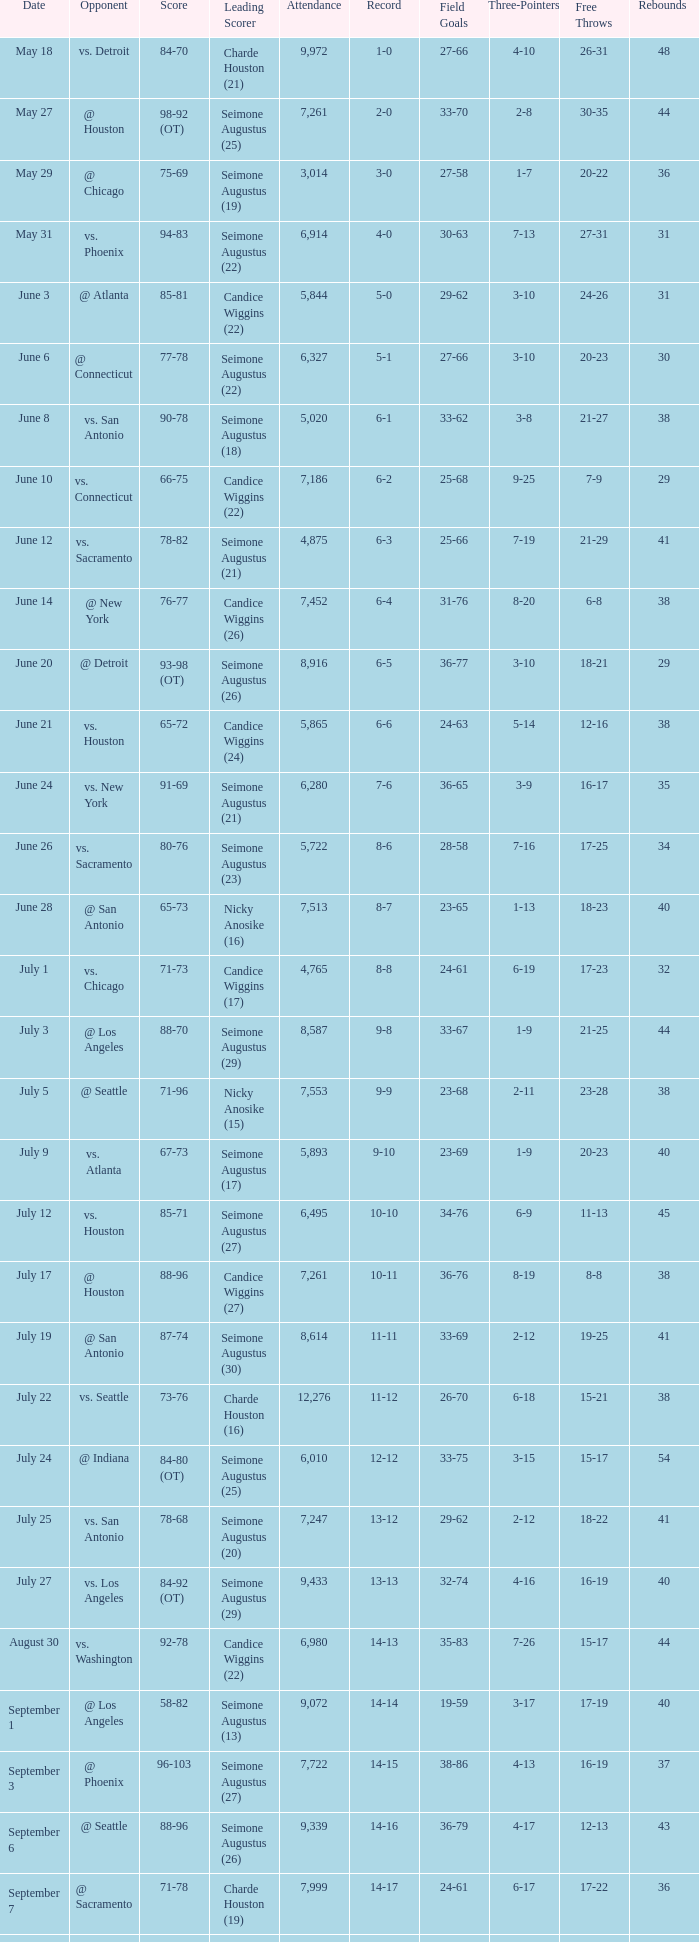Could you parse the entire table? {'header': ['Date', 'Opponent', 'Score', 'Leading Scorer', 'Attendance', 'Record', 'Field Goals', 'Three-Pointers', 'Free Throws', 'Rebounds '], 'rows': [['May 18', 'vs. Detroit', '84-70', 'Charde Houston (21)', '9,972', '1-0', '27-66', '4-10', '26-31', '48'], ['May 27', '@ Houston', '98-92 (OT)', 'Seimone Augustus (25)', '7,261', '2-0', '33-70', '2-8', '30-35', '44'], ['May 29', '@ Chicago', '75-69', 'Seimone Augustus (19)', '3,014', '3-0', '27-58', '1-7', '20-22', '36'], ['May 31', 'vs. Phoenix', '94-83', 'Seimone Augustus (22)', '6,914', '4-0', '30-63', '7-13', '27-31', '31'], ['June 3', '@ Atlanta', '85-81', 'Candice Wiggins (22)', '5,844', '5-0', '29-62', '3-10', '24-26', '31'], ['June 6', '@ Connecticut', '77-78', 'Seimone Augustus (22)', '6,327', '5-1', '27-66', '3-10', '20-23', '30'], ['June 8', 'vs. San Antonio', '90-78', 'Seimone Augustus (18)', '5,020', '6-1', '33-62', '3-8', '21-27', '38'], ['June 10', 'vs. Connecticut', '66-75', 'Candice Wiggins (22)', '7,186', '6-2', '25-68', '9-25', '7-9', '29'], ['June 12', 'vs. Sacramento', '78-82', 'Seimone Augustus (21)', '4,875', '6-3', '25-66', '7-19', '21-29', '41'], ['June 14', '@ New York', '76-77', 'Candice Wiggins (26)', '7,452', '6-4', '31-76', '8-20', '6-8', '38'], ['June 20', '@ Detroit', '93-98 (OT)', 'Seimone Augustus (26)', '8,916', '6-5', '36-77', '3-10', '18-21', '29'], ['June 21', 'vs. Houston', '65-72', 'Candice Wiggins (24)', '5,865', '6-6', '24-63', '5-14', '12-16', '38'], ['June 24', 'vs. New York', '91-69', 'Seimone Augustus (21)', '6,280', '7-6', '36-65', '3-9', '16-17', '35'], ['June 26', 'vs. Sacramento', '80-76', 'Seimone Augustus (23)', '5,722', '8-6', '28-58', '7-16', '17-25', '34'], ['June 28', '@ San Antonio', '65-73', 'Nicky Anosike (16)', '7,513', '8-7', '23-65', '1-13', '18-23', '40'], ['July 1', 'vs. Chicago', '71-73', 'Candice Wiggins (17)', '4,765', '8-8', '24-61', '6-19', '17-23', '32'], ['July 3', '@ Los Angeles', '88-70', 'Seimone Augustus (29)', '8,587', '9-8', '33-67', '1-9', '21-25', '44'], ['July 5', '@ Seattle', '71-96', 'Nicky Anosike (15)', '7,553', '9-9', '23-68', '2-11', '23-28', '38'], ['July 9', 'vs. Atlanta', '67-73', 'Seimone Augustus (17)', '5,893', '9-10', '23-69', '1-9', '20-23', '40'], ['July 12', 'vs. Houston', '85-71', 'Seimone Augustus (27)', '6,495', '10-10', '34-76', '6-9', '11-13', '45'], ['July 17', '@ Houston', '88-96', 'Candice Wiggins (27)', '7,261', '10-11', '36-76', '8-19', '8-8', '38'], ['July 19', '@ San Antonio', '87-74', 'Seimone Augustus (30)', '8,614', '11-11', '33-69', '2-12', '19-25', '41'], ['July 22', 'vs. Seattle', '73-76', 'Charde Houston (16)', '12,276', '11-12', '26-70', '6-18', '15-21', '38'], ['July 24', '@ Indiana', '84-80 (OT)', 'Seimone Augustus (25)', '6,010', '12-12', '33-75', '3-15', '15-17', '54'], ['July 25', 'vs. San Antonio', '78-68', 'Seimone Augustus (20)', '7,247', '13-12', '29-62', '2-12', '18-22', '41'], ['July 27', 'vs. Los Angeles', '84-92 (OT)', 'Seimone Augustus (29)', '9,433', '13-13', '32-74', '4-16', '16-19', '40'], ['August 30', 'vs. Washington', '92-78', 'Candice Wiggins (22)', '6,980', '14-13', '35-83', '7-26', '15-17', '44'], ['September 1', '@ Los Angeles', '58-82', 'Seimone Augustus (13)', '9,072', '14-14', '19-59', '3-17', '17-19', '40'], ['September 3', '@ Phoenix', '96-103', 'Seimone Augustus (27)', '7,722', '14-15', '38-86', '4-13', '16-19', '37'], ['September 6', '@ Seattle', '88-96', 'Seimone Augustus (26)', '9,339', '14-16', '36-79', '4-17', '12-13', '43'], ['September 7', '@ Sacramento', '71-78', 'Charde Houston (19)', '7,999', '14-17', '24-61', '6-17', '17-22', '36'], ['September 9', 'vs. Indiana', '86-76', 'Charde Houston (18)', '6,706', '15-17', '30-67', '3-21', '23-28', '47'], ['September 12', 'vs. Phoenix', '87-96', 'Lindsey Harding (20)', '8,343', '15-18', '33-71', '5-20', '16-24', '44'], ['September 14', '@ Washington', '96-70', 'Charde Houston (18)', '10,438', '16-18', '36-77', '3-11', '21-21', '44']]} Which Attendance has a Date of september 7? 7999.0. 